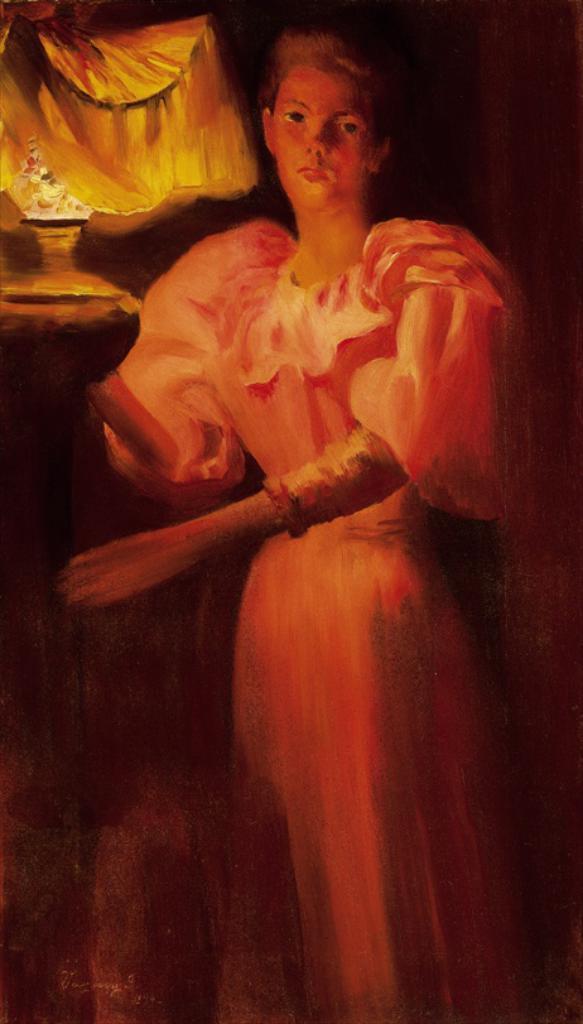How would you summarize this image in a sentence or two? In this image I can see a painting of a woman standing. 